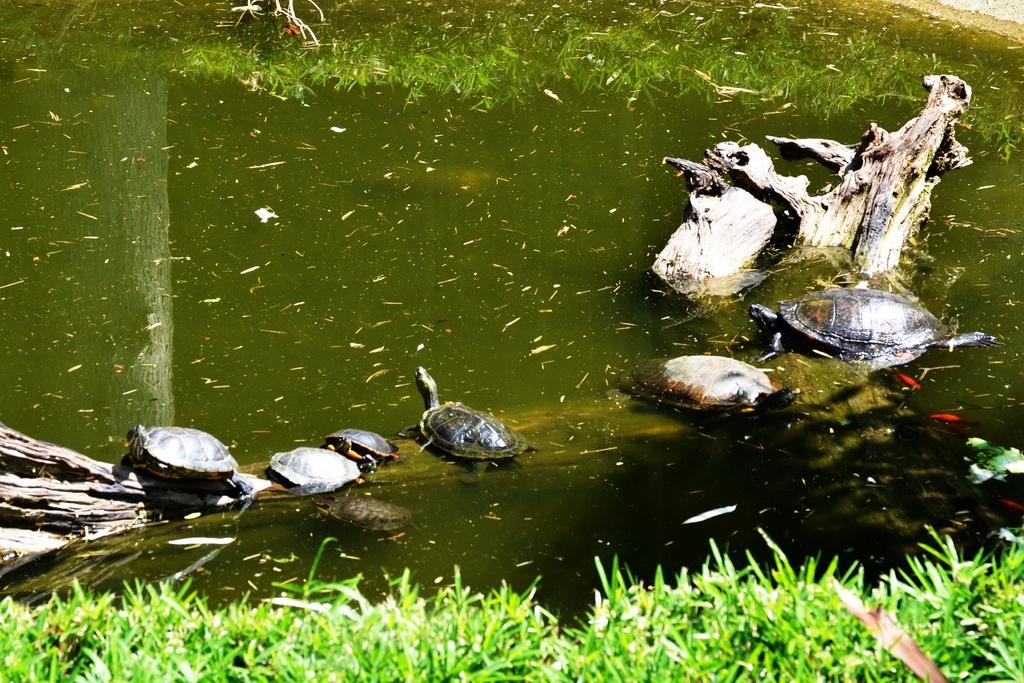What is partially submerged in the water in the image? There is a tree trunk in the water in the image. What type of animals can be seen on the tree trunk? There are small tortoises on the tree trunk. What type of vegetation is visible at the bottom of the image? There is grass at the bottom of the image. What is the main element occupying the middle of the image? There is water in the middle of the image. What type of office equipment can be seen on the tree trunk? There is no office equipment present in the image; it features a tree trunk with small tortoises. What is the cause of death for the tortoises in the image? There is no indication of death in the image; the tortoises are alive and on the tree trunk. 